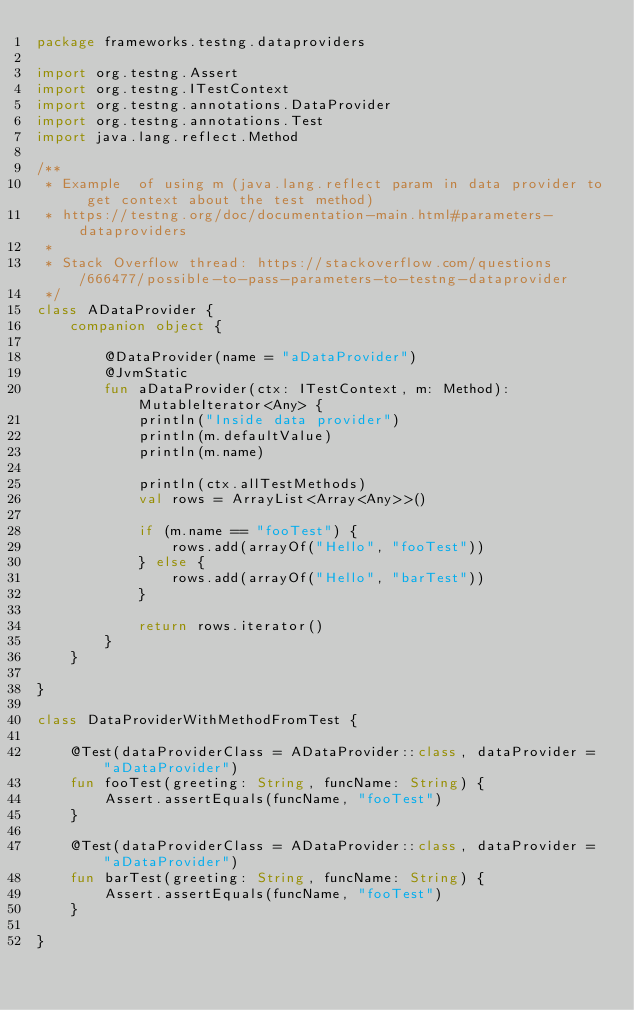<code> <loc_0><loc_0><loc_500><loc_500><_Kotlin_>package frameworks.testng.dataproviders

import org.testng.Assert
import org.testng.ITestContext
import org.testng.annotations.DataProvider
import org.testng.annotations.Test
import java.lang.reflect.Method

/**
 * Example  of using m (java.lang.reflect param in data provider to get context about the test method)
 * https://testng.org/doc/documentation-main.html#parameters-dataproviders
 *
 * Stack Overflow thread: https://stackoverflow.com/questions/666477/possible-to-pass-parameters-to-testng-dataprovider
 */
class ADataProvider {
    companion object {

        @DataProvider(name = "aDataProvider")
        @JvmStatic
        fun aDataProvider(ctx: ITestContext, m: Method): MutableIterator<Any> {
            println("Inside data provider")
            println(m.defaultValue)
            println(m.name)

            println(ctx.allTestMethods)
            val rows = ArrayList<Array<Any>>()

            if (m.name == "fooTest") {
                rows.add(arrayOf("Hello", "fooTest"))
            } else {
                rows.add(arrayOf("Hello", "barTest"))
            }

            return rows.iterator()
        }
    }

}

class DataProviderWithMethodFromTest {

    @Test(dataProviderClass = ADataProvider::class, dataProvider = "aDataProvider")
    fun fooTest(greeting: String, funcName: String) {
        Assert.assertEquals(funcName, "fooTest")
    }

    @Test(dataProviderClass = ADataProvider::class, dataProvider = "aDataProvider")
    fun barTest(greeting: String, funcName: String) {
        Assert.assertEquals(funcName, "fooTest")
    }

}</code> 